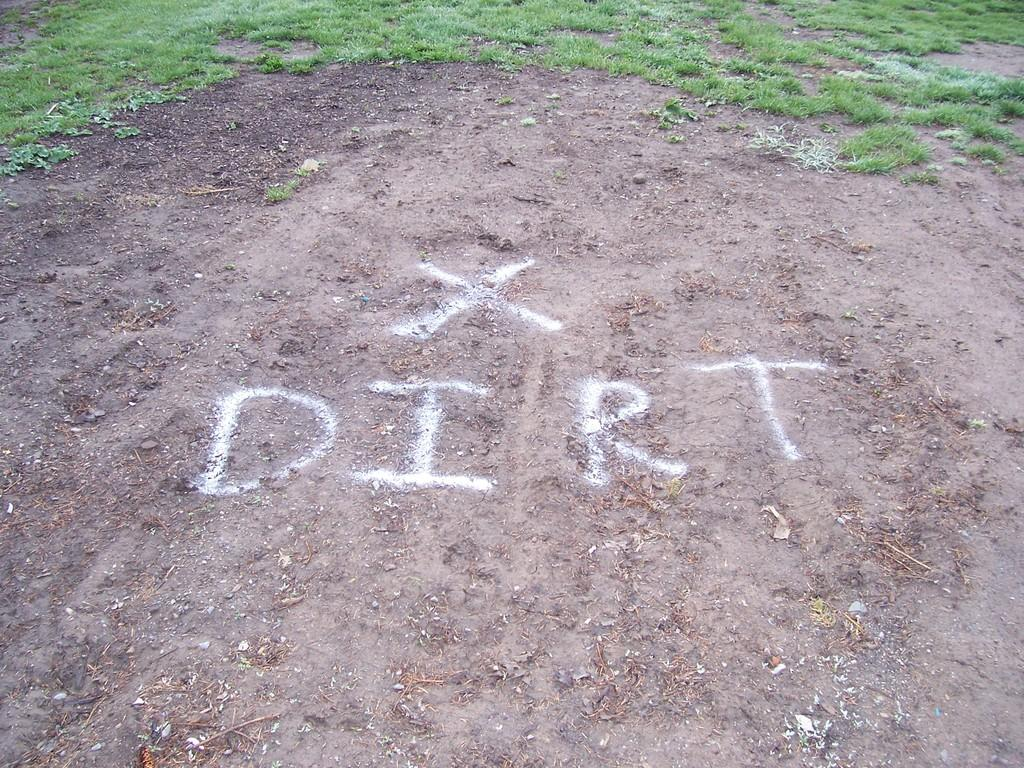What type of terrain is depicted in the image? There is a plain land in the image. What is written on the plain land? The word "DIRT" is written on the plain land. What type of vegetation is present in front of the plain land? There is grass in front of the plain land. How does the hose help with the production of the grass in the image? There is no hose present in the image, so it cannot help with the production of the grass. 